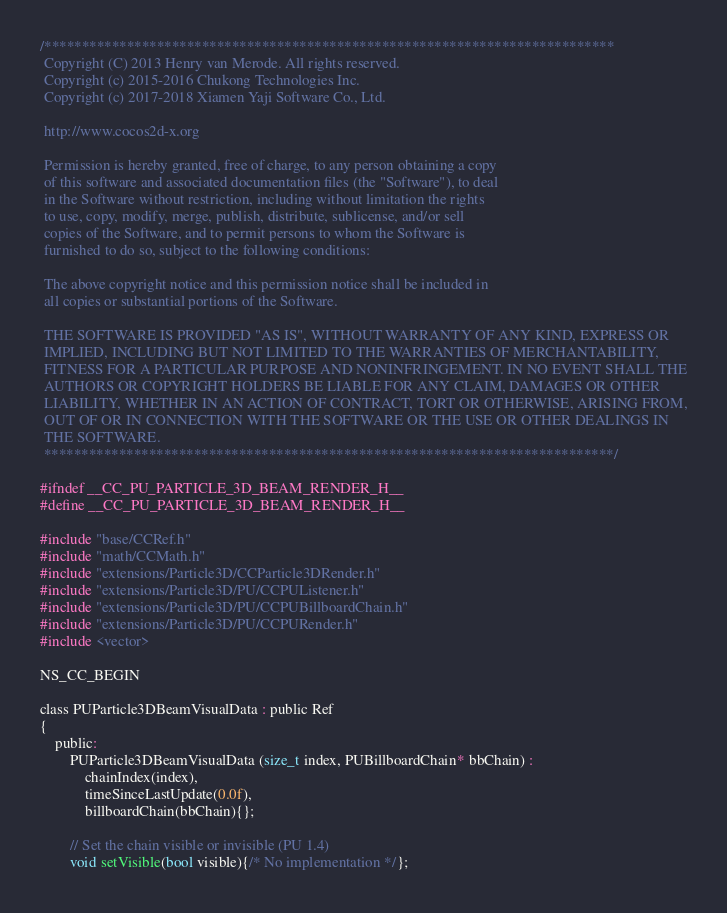Convert code to text. <code><loc_0><loc_0><loc_500><loc_500><_C_>/****************************************************************************
 Copyright (C) 2013 Henry van Merode. All rights reserved.
 Copyright (c) 2015-2016 Chukong Technologies Inc.
 Copyright (c) 2017-2018 Xiamen Yaji Software Co., Ltd.
 
 http://www.cocos2d-x.org
 
 Permission is hereby granted, free of charge, to any person obtaining a copy
 of this software and associated documentation files (the "Software"), to deal
 in the Software without restriction, including without limitation the rights
 to use, copy, modify, merge, publish, distribute, sublicense, and/or sell
 copies of the Software, and to permit persons to whom the Software is
 furnished to do so, subject to the following conditions:
 
 The above copyright notice and this permission notice shall be included in
 all copies or substantial portions of the Software.
 
 THE SOFTWARE IS PROVIDED "AS IS", WITHOUT WARRANTY OF ANY KIND, EXPRESS OR
 IMPLIED, INCLUDING BUT NOT LIMITED TO THE WARRANTIES OF MERCHANTABILITY,
 FITNESS FOR A PARTICULAR PURPOSE AND NONINFRINGEMENT. IN NO EVENT SHALL THE
 AUTHORS OR COPYRIGHT HOLDERS BE LIABLE FOR ANY CLAIM, DAMAGES OR OTHER
 LIABILITY, WHETHER IN AN ACTION OF CONTRACT, TORT OR OTHERWISE, ARISING FROM,
 OUT OF OR IN CONNECTION WITH THE SOFTWARE OR THE USE OR OTHER DEALINGS IN
 THE SOFTWARE.
 ****************************************************************************/

#ifndef __CC_PU_PARTICLE_3D_BEAM_RENDER_H__
#define __CC_PU_PARTICLE_3D_BEAM_RENDER_H__

#include "base/CCRef.h"
#include "math/CCMath.h"
#include "extensions/Particle3D/CCParticle3DRender.h"
#include "extensions/Particle3D/PU/CCPUListener.h"
#include "extensions/Particle3D/PU/CCPUBillboardChain.h"
#include "extensions/Particle3D/PU/CCPURender.h"
#include <vector>

NS_CC_BEGIN

class PUParticle3DBeamVisualData : public Ref
{
    public:
        PUParticle3DBeamVisualData (size_t index, PUBillboardChain* bbChain) :
            chainIndex(index),
            timeSinceLastUpdate(0.0f),
            billboardChain(bbChain){};

        // Set the chain visible or invisible (PU 1.4)
        void setVisible(bool visible){/* No implementation */};
</code> 